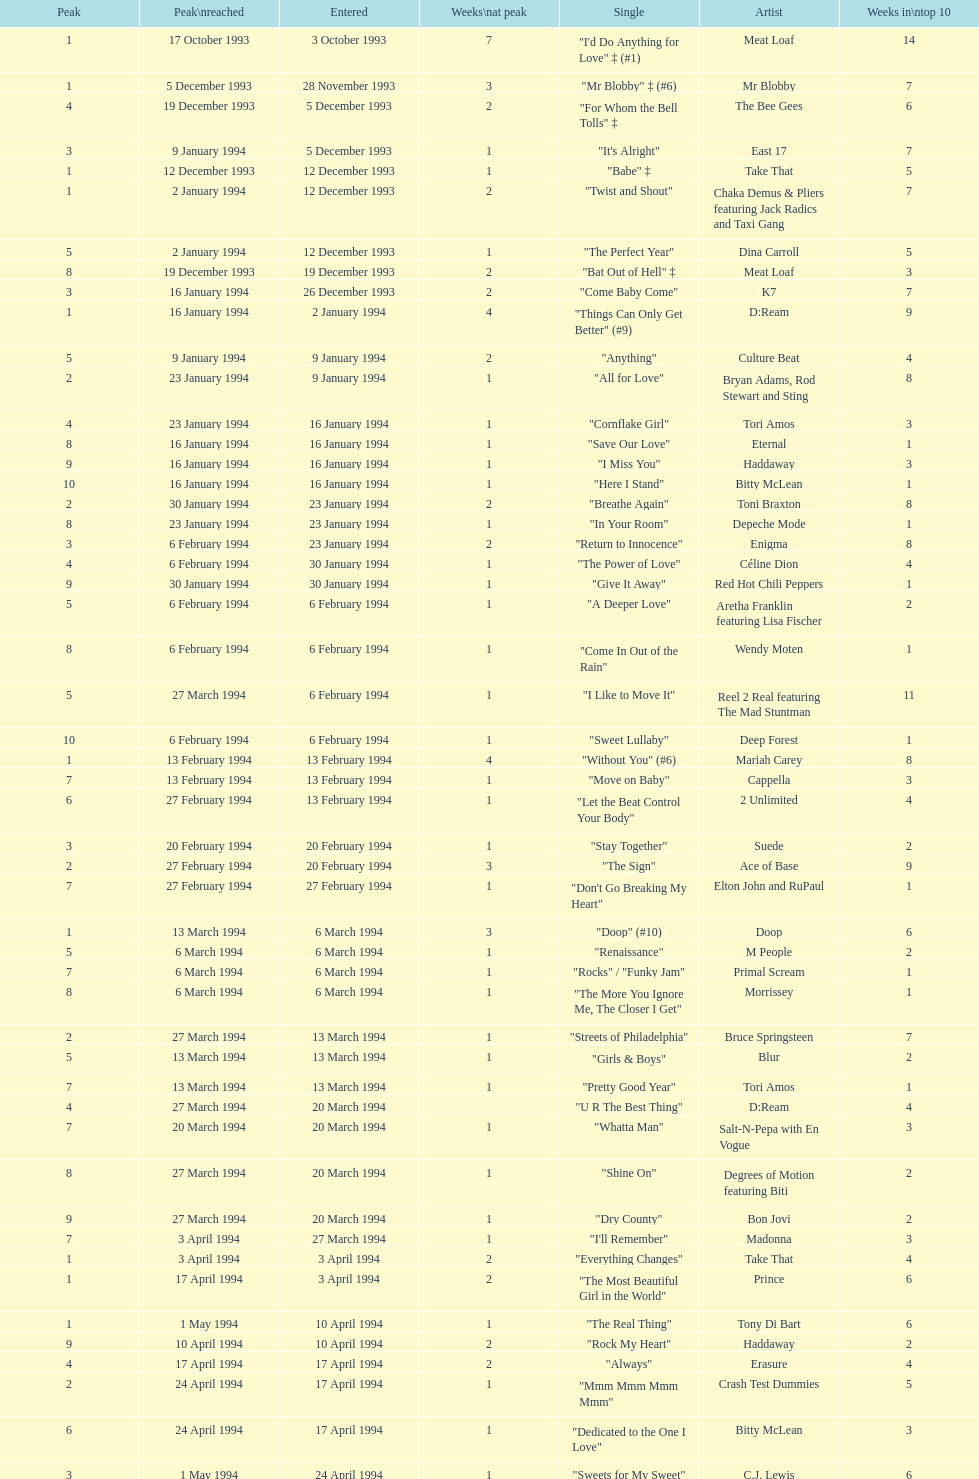Which single was the last one to be on the charts in 1993? "Come Baby Come". 